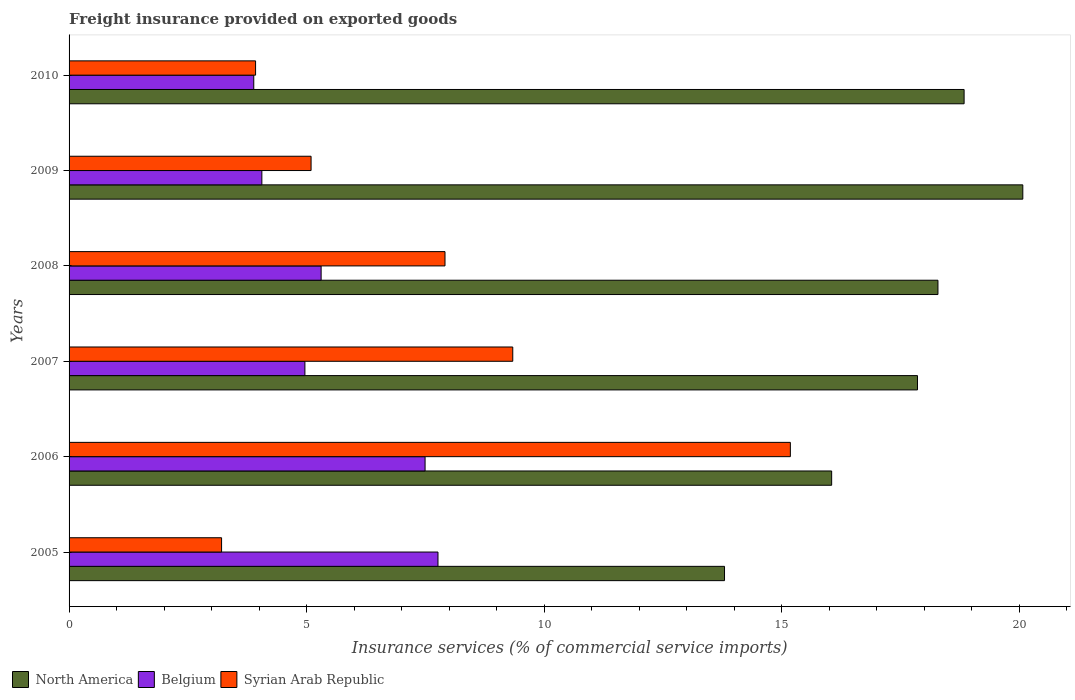Are the number of bars on each tick of the Y-axis equal?
Keep it short and to the point. Yes. How many bars are there on the 5th tick from the top?
Your response must be concise. 3. How many bars are there on the 5th tick from the bottom?
Offer a very short reply. 3. What is the label of the 5th group of bars from the top?
Provide a succinct answer. 2006. In how many cases, is the number of bars for a given year not equal to the number of legend labels?
Your answer should be compact. 0. What is the freight insurance provided on exported goods in Syrian Arab Republic in 2005?
Your answer should be very brief. 3.21. Across all years, what is the maximum freight insurance provided on exported goods in Syrian Arab Republic?
Ensure brevity in your answer.  15.18. Across all years, what is the minimum freight insurance provided on exported goods in Belgium?
Your answer should be very brief. 3.89. In which year was the freight insurance provided on exported goods in Belgium minimum?
Offer a very short reply. 2010. What is the total freight insurance provided on exported goods in Belgium in the graph?
Provide a succinct answer. 33.47. What is the difference between the freight insurance provided on exported goods in North America in 2006 and that in 2008?
Make the answer very short. -2.24. What is the difference between the freight insurance provided on exported goods in Syrian Arab Republic in 2010 and the freight insurance provided on exported goods in North America in 2007?
Offer a very short reply. -13.93. What is the average freight insurance provided on exported goods in Belgium per year?
Ensure brevity in your answer.  5.58. In the year 2005, what is the difference between the freight insurance provided on exported goods in Belgium and freight insurance provided on exported goods in Syrian Arab Republic?
Ensure brevity in your answer.  4.56. In how many years, is the freight insurance provided on exported goods in North America greater than 16 %?
Offer a terse response. 5. What is the ratio of the freight insurance provided on exported goods in Belgium in 2005 to that in 2008?
Provide a succinct answer. 1.46. Is the freight insurance provided on exported goods in Belgium in 2006 less than that in 2008?
Your response must be concise. No. Is the difference between the freight insurance provided on exported goods in Belgium in 2008 and 2009 greater than the difference between the freight insurance provided on exported goods in Syrian Arab Republic in 2008 and 2009?
Provide a short and direct response. No. What is the difference between the highest and the second highest freight insurance provided on exported goods in North America?
Make the answer very short. 1.24. What is the difference between the highest and the lowest freight insurance provided on exported goods in Belgium?
Give a very brief answer. 3.88. How many bars are there?
Your response must be concise. 18. What is the difference between two consecutive major ticks on the X-axis?
Your response must be concise. 5. Are the values on the major ticks of X-axis written in scientific E-notation?
Offer a terse response. No. Does the graph contain any zero values?
Give a very brief answer. No. Does the graph contain grids?
Your answer should be compact. No. Where does the legend appear in the graph?
Offer a terse response. Bottom left. How are the legend labels stacked?
Offer a very short reply. Horizontal. What is the title of the graph?
Make the answer very short. Freight insurance provided on exported goods. Does "Dominican Republic" appear as one of the legend labels in the graph?
Offer a very short reply. No. What is the label or title of the X-axis?
Your answer should be compact. Insurance services (% of commercial service imports). What is the Insurance services (% of commercial service imports) of North America in 2005?
Ensure brevity in your answer.  13.8. What is the Insurance services (% of commercial service imports) of Belgium in 2005?
Keep it short and to the point. 7.77. What is the Insurance services (% of commercial service imports) in Syrian Arab Republic in 2005?
Keep it short and to the point. 3.21. What is the Insurance services (% of commercial service imports) in North America in 2006?
Your answer should be very brief. 16.05. What is the Insurance services (% of commercial service imports) in Belgium in 2006?
Your response must be concise. 7.49. What is the Insurance services (% of commercial service imports) of Syrian Arab Republic in 2006?
Provide a short and direct response. 15.18. What is the Insurance services (% of commercial service imports) of North America in 2007?
Offer a very short reply. 17.86. What is the Insurance services (% of commercial service imports) in Belgium in 2007?
Provide a succinct answer. 4.96. What is the Insurance services (% of commercial service imports) of Syrian Arab Republic in 2007?
Ensure brevity in your answer.  9.34. What is the Insurance services (% of commercial service imports) in North America in 2008?
Offer a terse response. 18.29. What is the Insurance services (% of commercial service imports) of Belgium in 2008?
Make the answer very short. 5.31. What is the Insurance services (% of commercial service imports) in Syrian Arab Republic in 2008?
Keep it short and to the point. 7.91. What is the Insurance services (% of commercial service imports) in North America in 2009?
Keep it short and to the point. 20.08. What is the Insurance services (% of commercial service imports) in Belgium in 2009?
Offer a very short reply. 4.06. What is the Insurance services (% of commercial service imports) of Syrian Arab Republic in 2009?
Your answer should be compact. 5.09. What is the Insurance services (% of commercial service imports) in North America in 2010?
Your answer should be very brief. 18.84. What is the Insurance services (% of commercial service imports) in Belgium in 2010?
Offer a terse response. 3.89. What is the Insurance services (% of commercial service imports) of Syrian Arab Republic in 2010?
Keep it short and to the point. 3.93. Across all years, what is the maximum Insurance services (% of commercial service imports) of North America?
Offer a very short reply. 20.08. Across all years, what is the maximum Insurance services (% of commercial service imports) in Belgium?
Offer a very short reply. 7.77. Across all years, what is the maximum Insurance services (% of commercial service imports) of Syrian Arab Republic?
Your answer should be compact. 15.18. Across all years, what is the minimum Insurance services (% of commercial service imports) in North America?
Your answer should be very brief. 13.8. Across all years, what is the minimum Insurance services (% of commercial service imports) in Belgium?
Provide a succinct answer. 3.89. Across all years, what is the minimum Insurance services (% of commercial service imports) in Syrian Arab Republic?
Your response must be concise. 3.21. What is the total Insurance services (% of commercial service imports) of North America in the graph?
Your response must be concise. 104.91. What is the total Insurance services (% of commercial service imports) of Belgium in the graph?
Provide a short and direct response. 33.47. What is the total Insurance services (% of commercial service imports) of Syrian Arab Republic in the graph?
Keep it short and to the point. 44.66. What is the difference between the Insurance services (% of commercial service imports) in North America in 2005 and that in 2006?
Make the answer very short. -2.26. What is the difference between the Insurance services (% of commercial service imports) of Belgium in 2005 and that in 2006?
Provide a succinct answer. 0.27. What is the difference between the Insurance services (% of commercial service imports) in Syrian Arab Republic in 2005 and that in 2006?
Provide a succinct answer. -11.97. What is the difference between the Insurance services (% of commercial service imports) of North America in 2005 and that in 2007?
Ensure brevity in your answer.  -4.06. What is the difference between the Insurance services (% of commercial service imports) of Belgium in 2005 and that in 2007?
Your response must be concise. 2.8. What is the difference between the Insurance services (% of commercial service imports) in Syrian Arab Republic in 2005 and that in 2007?
Your answer should be very brief. -6.13. What is the difference between the Insurance services (% of commercial service imports) of North America in 2005 and that in 2008?
Your response must be concise. -4.49. What is the difference between the Insurance services (% of commercial service imports) of Belgium in 2005 and that in 2008?
Offer a terse response. 2.46. What is the difference between the Insurance services (% of commercial service imports) of Syrian Arab Republic in 2005 and that in 2008?
Make the answer very short. -4.7. What is the difference between the Insurance services (% of commercial service imports) in North America in 2005 and that in 2009?
Keep it short and to the point. -6.28. What is the difference between the Insurance services (% of commercial service imports) in Belgium in 2005 and that in 2009?
Your answer should be compact. 3.71. What is the difference between the Insurance services (% of commercial service imports) of Syrian Arab Republic in 2005 and that in 2009?
Give a very brief answer. -1.88. What is the difference between the Insurance services (% of commercial service imports) of North America in 2005 and that in 2010?
Offer a very short reply. -5.04. What is the difference between the Insurance services (% of commercial service imports) of Belgium in 2005 and that in 2010?
Ensure brevity in your answer.  3.88. What is the difference between the Insurance services (% of commercial service imports) in Syrian Arab Republic in 2005 and that in 2010?
Provide a short and direct response. -0.72. What is the difference between the Insurance services (% of commercial service imports) of North America in 2006 and that in 2007?
Offer a terse response. -1.81. What is the difference between the Insurance services (% of commercial service imports) in Belgium in 2006 and that in 2007?
Give a very brief answer. 2.53. What is the difference between the Insurance services (% of commercial service imports) in Syrian Arab Republic in 2006 and that in 2007?
Give a very brief answer. 5.84. What is the difference between the Insurance services (% of commercial service imports) of North America in 2006 and that in 2008?
Your answer should be very brief. -2.24. What is the difference between the Insurance services (% of commercial service imports) in Belgium in 2006 and that in 2008?
Keep it short and to the point. 2.19. What is the difference between the Insurance services (% of commercial service imports) in Syrian Arab Republic in 2006 and that in 2008?
Provide a succinct answer. 7.27. What is the difference between the Insurance services (% of commercial service imports) in North America in 2006 and that in 2009?
Give a very brief answer. -4.02. What is the difference between the Insurance services (% of commercial service imports) in Belgium in 2006 and that in 2009?
Provide a short and direct response. 3.44. What is the difference between the Insurance services (% of commercial service imports) of Syrian Arab Republic in 2006 and that in 2009?
Keep it short and to the point. 10.09. What is the difference between the Insurance services (% of commercial service imports) of North America in 2006 and that in 2010?
Give a very brief answer. -2.79. What is the difference between the Insurance services (% of commercial service imports) of Belgium in 2006 and that in 2010?
Your answer should be very brief. 3.61. What is the difference between the Insurance services (% of commercial service imports) in Syrian Arab Republic in 2006 and that in 2010?
Your answer should be very brief. 11.26. What is the difference between the Insurance services (% of commercial service imports) in North America in 2007 and that in 2008?
Give a very brief answer. -0.43. What is the difference between the Insurance services (% of commercial service imports) in Belgium in 2007 and that in 2008?
Offer a terse response. -0.34. What is the difference between the Insurance services (% of commercial service imports) in Syrian Arab Republic in 2007 and that in 2008?
Your answer should be compact. 1.43. What is the difference between the Insurance services (% of commercial service imports) in North America in 2007 and that in 2009?
Provide a short and direct response. -2.22. What is the difference between the Insurance services (% of commercial service imports) in Belgium in 2007 and that in 2009?
Offer a very short reply. 0.91. What is the difference between the Insurance services (% of commercial service imports) in Syrian Arab Republic in 2007 and that in 2009?
Your answer should be compact. 4.25. What is the difference between the Insurance services (% of commercial service imports) in North America in 2007 and that in 2010?
Keep it short and to the point. -0.98. What is the difference between the Insurance services (% of commercial service imports) of Belgium in 2007 and that in 2010?
Keep it short and to the point. 1.08. What is the difference between the Insurance services (% of commercial service imports) in Syrian Arab Republic in 2007 and that in 2010?
Provide a succinct answer. 5.41. What is the difference between the Insurance services (% of commercial service imports) of North America in 2008 and that in 2009?
Provide a short and direct response. -1.79. What is the difference between the Insurance services (% of commercial service imports) in Belgium in 2008 and that in 2009?
Ensure brevity in your answer.  1.25. What is the difference between the Insurance services (% of commercial service imports) in Syrian Arab Republic in 2008 and that in 2009?
Your answer should be very brief. 2.82. What is the difference between the Insurance services (% of commercial service imports) in North America in 2008 and that in 2010?
Offer a terse response. -0.55. What is the difference between the Insurance services (% of commercial service imports) of Belgium in 2008 and that in 2010?
Your response must be concise. 1.42. What is the difference between the Insurance services (% of commercial service imports) in Syrian Arab Republic in 2008 and that in 2010?
Offer a very short reply. 3.99. What is the difference between the Insurance services (% of commercial service imports) in North America in 2009 and that in 2010?
Provide a short and direct response. 1.24. What is the difference between the Insurance services (% of commercial service imports) of Belgium in 2009 and that in 2010?
Keep it short and to the point. 0.17. What is the difference between the Insurance services (% of commercial service imports) in Syrian Arab Republic in 2009 and that in 2010?
Your response must be concise. 1.17. What is the difference between the Insurance services (% of commercial service imports) in North America in 2005 and the Insurance services (% of commercial service imports) in Belgium in 2006?
Keep it short and to the point. 6.3. What is the difference between the Insurance services (% of commercial service imports) of North America in 2005 and the Insurance services (% of commercial service imports) of Syrian Arab Republic in 2006?
Offer a very short reply. -1.39. What is the difference between the Insurance services (% of commercial service imports) in Belgium in 2005 and the Insurance services (% of commercial service imports) in Syrian Arab Republic in 2006?
Give a very brief answer. -7.42. What is the difference between the Insurance services (% of commercial service imports) of North America in 2005 and the Insurance services (% of commercial service imports) of Belgium in 2007?
Make the answer very short. 8.83. What is the difference between the Insurance services (% of commercial service imports) in North America in 2005 and the Insurance services (% of commercial service imports) in Syrian Arab Republic in 2007?
Your answer should be compact. 4.46. What is the difference between the Insurance services (% of commercial service imports) in Belgium in 2005 and the Insurance services (% of commercial service imports) in Syrian Arab Republic in 2007?
Your answer should be compact. -1.57. What is the difference between the Insurance services (% of commercial service imports) in North America in 2005 and the Insurance services (% of commercial service imports) in Belgium in 2008?
Offer a terse response. 8.49. What is the difference between the Insurance services (% of commercial service imports) of North America in 2005 and the Insurance services (% of commercial service imports) of Syrian Arab Republic in 2008?
Offer a terse response. 5.88. What is the difference between the Insurance services (% of commercial service imports) of Belgium in 2005 and the Insurance services (% of commercial service imports) of Syrian Arab Republic in 2008?
Make the answer very short. -0.15. What is the difference between the Insurance services (% of commercial service imports) in North America in 2005 and the Insurance services (% of commercial service imports) in Belgium in 2009?
Your answer should be very brief. 9.74. What is the difference between the Insurance services (% of commercial service imports) of North America in 2005 and the Insurance services (% of commercial service imports) of Syrian Arab Republic in 2009?
Your answer should be compact. 8.7. What is the difference between the Insurance services (% of commercial service imports) in Belgium in 2005 and the Insurance services (% of commercial service imports) in Syrian Arab Republic in 2009?
Make the answer very short. 2.67. What is the difference between the Insurance services (% of commercial service imports) in North America in 2005 and the Insurance services (% of commercial service imports) in Belgium in 2010?
Keep it short and to the point. 9.91. What is the difference between the Insurance services (% of commercial service imports) in North America in 2005 and the Insurance services (% of commercial service imports) in Syrian Arab Republic in 2010?
Ensure brevity in your answer.  9.87. What is the difference between the Insurance services (% of commercial service imports) of Belgium in 2005 and the Insurance services (% of commercial service imports) of Syrian Arab Republic in 2010?
Give a very brief answer. 3.84. What is the difference between the Insurance services (% of commercial service imports) of North America in 2006 and the Insurance services (% of commercial service imports) of Belgium in 2007?
Keep it short and to the point. 11.09. What is the difference between the Insurance services (% of commercial service imports) in North America in 2006 and the Insurance services (% of commercial service imports) in Syrian Arab Republic in 2007?
Provide a short and direct response. 6.71. What is the difference between the Insurance services (% of commercial service imports) in Belgium in 2006 and the Insurance services (% of commercial service imports) in Syrian Arab Republic in 2007?
Provide a short and direct response. -1.85. What is the difference between the Insurance services (% of commercial service imports) in North America in 2006 and the Insurance services (% of commercial service imports) in Belgium in 2008?
Make the answer very short. 10.75. What is the difference between the Insurance services (% of commercial service imports) of North America in 2006 and the Insurance services (% of commercial service imports) of Syrian Arab Republic in 2008?
Provide a short and direct response. 8.14. What is the difference between the Insurance services (% of commercial service imports) in Belgium in 2006 and the Insurance services (% of commercial service imports) in Syrian Arab Republic in 2008?
Make the answer very short. -0.42. What is the difference between the Insurance services (% of commercial service imports) in North America in 2006 and the Insurance services (% of commercial service imports) in Belgium in 2009?
Ensure brevity in your answer.  11.99. What is the difference between the Insurance services (% of commercial service imports) in North America in 2006 and the Insurance services (% of commercial service imports) in Syrian Arab Republic in 2009?
Your response must be concise. 10.96. What is the difference between the Insurance services (% of commercial service imports) in Belgium in 2006 and the Insurance services (% of commercial service imports) in Syrian Arab Republic in 2009?
Your answer should be compact. 2.4. What is the difference between the Insurance services (% of commercial service imports) in North America in 2006 and the Insurance services (% of commercial service imports) in Belgium in 2010?
Give a very brief answer. 12.16. What is the difference between the Insurance services (% of commercial service imports) of North America in 2006 and the Insurance services (% of commercial service imports) of Syrian Arab Republic in 2010?
Keep it short and to the point. 12.13. What is the difference between the Insurance services (% of commercial service imports) in Belgium in 2006 and the Insurance services (% of commercial service imports) in Syrian Arab Republic in 2010?
Offer a very short reply. 3.57. What is the difference between the Insurance services (% of commercial service imports) of North America in 2007 and the Insurance services (% of commercial service imports) of Belgium in 2008?
Offer a very short reply. 12.55. What is the difference between the Insurance services (% of commercial service imports) in North America in 2007 and the Insurance services (% of commercial service imports) in Syrian Arab Republic in 2008?
Give a very brief answer. 9.95. What is the difference between the Insurance services (% of commercial service imports) in Belgium in 2007 and the Insurance services (% of commercial service imports) in Syrian Arab Republic in 2008?
Offer a terse response. -2.95. What is the difference between the Insurance services (% of commercial service imports) in North America in 2007 and the Insurance services (% of commercial service imports) in Belgium in 2009?
Keep it short and to the point. 13.8. What is the difference between the Insurance services (% of commercial service imports) in North America in 2007 and the Insurance services (% of commercial service imports) in Syrian Arab Republic in 2009?
Your response must be concise. 12.76. What is the difference between the Insurance services (% of commercial service imports) in Belgium in 2007 and the Insurance services (% of commercial service imports) in Syrian Arab Republic in 2009?
Give a very brief answer. -0.13. What is the difference between the Insurance services (% of commercial service imports) in North America in 2007 and the Insurance services (% of commercial service imports) in Belgium in 2010?
Ensure brevity in your answer.  13.97. What is the difference between the Insurance services (% of commercial service imports) in North America in 2007 and the Insurance services (% of commercial service imports) in Syrian Arab Republic in 2010?
Keep it short and to the point. 13.93. What is the difference between the Insurance services (% of commercial service imports) of North America in 2008 and the Insurance services (% of commercial service imports) of Belgium in 2009?
Make the answer very short. 14.23. What is the difference between the Insurance services (% of commercial service imports) in North America in 2008 and the Insurance services (% of commercial service imports) in Syrian Arab Republic in 2009?
Your response must be concise. 13.2. What is the difference between the Insurance services (% of commercial service imports) of Belgium in 2008 and the Insurance services (% of commercial service imports) of Syrian Arab Republic in 2009?
Provide a succinct answer. 0.21. What is the difference between the Insurance services (% of commercial service imports) in North America in 2008 and the Insurance services (% of commercial service imports) in Belgium in 2010?
Ensure brevity in your answer.  14.4. What is the difference between the Insurance services (% of commercial service imports) of North America in 2008 and the Insurance services (% of commercial service imports) of Syrian Arab Republic in 2010?
Your answer should be compact. 14.36. What is the difference between the Insurance services (% of commercial service imports) in Belgium in 2008 and the Insurance services (% of commercial service imports) in Syrian Arab Republic in 2010?
Your response must be concise. 1.38. What is the difference between the Insurance services (% of commercial service imports) of North America in 2009 and the Insurance services (% of commercial service imports) of Belgium in 2010?
Keep it short and to the point. 16.19. What is the difference between the Insurance services (% of commercial service imports) of North America in 2009 and the Insurance services (% of commercial service imports) of Syrian Arab Republic in 2010?
Your answer should be very brief. 16.15. What is the difference between the Insurance services (% of commercial service imports) in Belgium in 2009 and the Insurance services (% of commercial service imports) in Syrian Arab Republic in 2010?
Make the answer very short. 0.13. What is the average Insurance services (% of commercial service imports) of North America per year?
Give a very brief answer. 17.49. What is the average Insurance services (% of commercial service imports) in Belgium per year?
Provide a succinct answer. 5.58. What is the average Insurance services (% of commercial service imports) in Syrian Arab Republic per year?
Give a very brief answer. 7.44. In the year 2005, what is the difference between the Insurance services (% of commercial service imports) in North America and Insurance services (% of commercial service imports) in Belgium?
Provide a succinct answer. 6.03. In the year 2005, what is the difference between the Insurance services (% of commercial service imports) of North America and Insurance services (% of commercial service imports) of Syrian Arab Republic?
Your answer should be very brief. 10.59. In the year 2005, what is the difference between the Insurance services (% of commercial service imports) in Belgium and Insurance services (% of commercial service imports) in Syrian Arab Republic?
Your answer should be very brief. 4.56. In the year 2006, what is the difference between the Insurance services (% of commercial service imports) of North America and Insurance services (% of commercial service imports) of Belgium?
Your response must be concise. 8.56. In the year 2006, what is the difference between the Insurance services (% of commercial service imports) of North America and Insurance services (% of commercial service imports) of Syrian Arab Republic?
Offer a very short reply. 0.87. In the year 2006, what is the difference between the Insurance services (% of commercial service imports) of Belgium and Insurance services (% of commercial service imports) of Syrian Arab Republic?
Make the answer very short. -7.69. In the year 2007, what is the difference between the Insurance services (% of commercial service imports) of North America and Insurance services (% of commercial service imports) of Belgium?
Your response must be concise. 12.89. In the year 2007, what is the difference between the Insurance services (% of commercial service imports) in North America and Insurance services (% of commercial service imports) in Syrian Arab Republic?
Your answer should be very brief. 8.52. In the year 2007, what is the difference between the Insurance services (% of commercial service imports) of Belgium and Insurance services (% of commercial service imports) of Syrian Arab Republic?
Provide a short and direct response. -4.38. In the year 2008, what is the difference between the Insurance services (% of commercial service imports) of North America and Insurance services (% of commercial service imports) of Belgium?
Ensure brevity in your answer.  12.98. In the year 2008, what is the difference between the Insurance services (% of commercial service imports) of North America and Insurance services (% of commercial service imports) of Syrian Arab Republic?
Offer a very short reply. 10.38. In the year 2008, what is the difference between the Insurance services (% of commercial service imports) in Belgium and Insurance services (% of commercial service imports) in Syrian Arab Republic?
Keep it short and to the point. -2.61. In the year 2009, what is the difference between the Insurance services (% of commercial service imports) in North America and Insurance services (% of commercial service imports) in Belgium?
Provide a succinct answer. 16.02. In the year 2009, what is the difference between the Insurance services (% of commercial service imports) in North America and Insurance services (% of commercial service imports) in Syrian Arab Republic?
Your answer should be compact. 14.98. In the year 2009, what is the difference between the Insurance services (% of commercial service imports) of Belgium and Insurance services (% of commercial service imports) of Syrian Arab Republic?
Offer a terse response. -1.04. In the year 2010, what is the difference between the Insurance services (% of commercial service imports) of North America and Insurance services (% of commercial service imports) of Belgium?
Provide a short and direct response. 14.95. In the year 2010, what is the difference between the Insurance services (% of commercial service imports) of North America and Insurance services (% of commercial service imports) of Syrian Arab Republic?
Provide a succinct answer. 14.91. In the year 2010, what is the difference between the Insurance services (% of commercial service imports) in Belgium and Insurance services (% of commercial service imports) in Syrian Arab Republic?
Give a very brief answer. -0.04. What is the ratio of the Insurance services (% of commercial service imports) in North America in 2005 to that in 2006?
Ensure brevity in your answer.  0.86. What is the ratio of the Insurance services (% of commercial service imports) of Belgium in 2005 to that in 2006?
Offer a very short reply. 1.04. What is the ratio of the Insurance services (% of commercial service imports) in Syrian Arab Republic in 2005 to that in 2006?
Ensure brevity in your answer.  0.21. What is the ratio of the Insurance services (% of commercial service imports) in North America in 2005 to that in 2007?
Offer a terse response. 0.77. What is the ratio of the Insurance services (% of commercial service imports) of Belgium in 2005 to that in 2007?
Your response must be concise. 1.56. What is the ratio of the Insurance services (% of commercial service imports) of Syrian Arab Republic in 2005 to that in 2007?
Your response must be concise. 0.34. What is the ratio of the Insurance services (% of commercial service imports) of North America in 2005 to that in 2008?
Offer a very short reply. 0.75. What is the ratio of the Insurance services (% of commercial service imports) of Belgium in 2005 to that in 2008?
Your answer should be very brief. 1.46. What is the ratio of the Insurance services (% of commercial service imports) of Syrian Arab Republic in 2005 to that in 2008?
Provide a succinct answer. 0.41. What is the ratio of the Insurance services (% of commercial service imports) in North America in 2005 to that in 2009?
Ensure brevity in your answer.  0.69. What is the ratio of the Insurance services (% of commercial service imports) of Belgium in 2005 to that in 2009?
Provide a short and direct response. 1.91. What is the ratio of the Insurance services (% of commercial service imports) of Syrian Arab Republic in 2005 to that in 2009?
Provide a succinct answer. 0.63. What is the ratio of the Insurance services (% of commercial service imports) in North America in 2005 to that in 2010?
Keep it short and to the point. 0.73. What is the ratio of the Insurance services (% of commercial service imports) in Belgium in 2005 to that in 2010?
Make the answer very short. 2. What is the ratio of the Insurance services (% of commercial service imports) in Syrian Arab Republic in 2005 to that in 2010?
Your answer should be very brief. 0.82. What is the ratio of the Insurance services (% of commercial service imports) in North America in 2006 to that in 2007?
Provide a succinct answer. 0.9. What is the ratio of the Insurance services (% of commercial service imports) of Belgium in 2006 to that in 2007?
Your answer should be very brief. 1.51. What is the ratio of the Insurance services (% of commercial service imports) of Syrian Arab Republic in 2006 to that in 2007?
Provide a short and direct response. 1.63. What is the ratio of the Insurance services (% of commercial service imports) of North America in 2006 to that in 2008?
Give a very brief answer. 0.88. What is the ratio of the Insurance services (% of commercial service imports) in Belgium in 2006 to that in 2008?
Offer a terse response. 1.41. What is the ratio of the Insurance services (% of commercial service imports) of Syrian Arab Republic in 2006 to that in 2008?
Your answer should be compact. 1.92. What is the ratio of the Insurance services (% of commercial service imports) in North America in 2006 to that in 2009?
Give a very brief answer. 0.8. What is the ratio of the Insurance services (% of commercial service imports) in Belgium in 2006 to that in 2009?
Your answer should be compact. 1.85. What is the ratio of the Insurance services (% of commercial service imports) of Syrian Arab Republic in 2006 to that in 2009?
Provide a succinct answer. 2.98. What is the ratio of the Insurance services (% of commercial service imports) in North America in 2006 to that in 2010?
Your answer should be compact. 0.85. What is the ratio of the Insurance services (% of commercial service imports) of Belgium in 2006 to that in 2010?
Provide a succinct answer. 1.93. What is the ratio of the Insurance services (% of commercial service imports) in Syrian Arab Republic in 2006 to that in 2010?
Offer a very short reply. 3.87. What is the ratio of the Insurance services (% of commercial service imports) of North America in 2007 to that in 2008?
Keep it short and to the point. 0.98. What is the ratio of the Insurance services (% of commercial service imports) in Belgium in 2007 to that in 2008?
Keep it short and to the point. 0.94. What is the ratio of the Insurance services (% of commercial service imports) of Syrian Arab Republic in 2007 to that in 2008?
Provide a short and direct response. 1.18. What is the ratio of the Insurance services (% of commercial service imports) in North America in 2007 to that in 2009?
Keep it short and to the point. 0.89. What is the ratio of the Insurance services (% of commercial service imports) of Belgium in 2007 to that in 2009?
Offer a very short reply. 1.22. What is the ratio of the Insurance services (% of commercial service imports) of Syrian Arab Republic in 2007 to that in 2009?
Ensure brevity in your answer.  1.83. What is the ratio of the Insurance services (% of commercial service imports) of North America in 2007 to that in 2010?
Your answer should be compact. 0.95. What is the ratio of the Insurance services (% of commercial service imports) in Belgium in 2007 to that in 2010?
Your response must be concise. 1.28. What is the ratio of the Insurance services (% of commercial service imports) of Syrian Arab Republic in 2007 to that in 2010?
Provide a succinct answer. 2.38. What is the ratio of the Insurance services (% of commercial service imports) of North America in 2008 to that in 2009?
Give a very brief answer. 0.91. What is the ratio of the Insurance services (% of commercial service imports) in Belgium in 2008 to that in 2009?
Keep it short and to the point. 1.31. What is the ratio of the Insurance services (% of commercial service imports) of Syrian Arab Republic in 2008 to that in 2009?
Your response must be concise. 1.55. What is the ratio of the Insurance services (% of commercial service imports) in North America in 2008 to that in 2010?
Ensure brevity in your answer.  0.97. What is the ratio of the Insurance services (% of commercial service imports) in Belgium in 2008 to that in 2010?
Make the answer very short. 1.36. What is the ratio of the Insurance services (% of commercial service imports) in Syrian Arab Republic in 2008 to that in 2010?
Keep it short and to the point. 2.02. What is the ratio of the Insurance services (% of commercial service imports) in North America in 2009 to that in 2010?
Offer a terse response. 1.07. What is the ratio of the Insurance services (% of commercial service imports) of Belgium in 2009 to that in 2010?
Keep it short and to the point. 1.04. What is the ratio of the Insurance services (% of commercial service imports) in Syrian Arab Republic in 2009 to that in 2010?
Your answer should be very brief. 1.3. What is the difference between the highest and the second highest Insurance services (% of commercial service imports) in North America?
Your response must be concise. 1.24. What is the difference between the highest and the second highest Insurance services (% of commercial service imports) in Belgium?
Keep it short and to the point. 0.27. What is the difference between the highest and the second highest Insurance services (% of commercial service imports) in Syrian Arab Republic?
Keep it short and to the point. 5.84. What is the difference between the highest and the lowest Insurance services (% of commercial service imports) of North America?
Provide a succinct answer. 6.28. What is the difference between the highest and the lowest Insurance services (% of commercial service imports) in Belgium?
Make the answer very short. 3.88. What is the difference between the highest and the lowest Insurance services (% of commercial service imports) of Syrian Arab Republic?
Give a very brief answer. 11.97. 